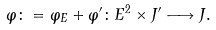Convert formula to latex. <formula><loc_0><loc_0><loc_500><loc_500>\varphi \colon = \varphi _ { E } + \varphi ^ { \prime } \colon E ^ { 2 } \times J ^ { \prime } \longrightarrow J .</formula> 